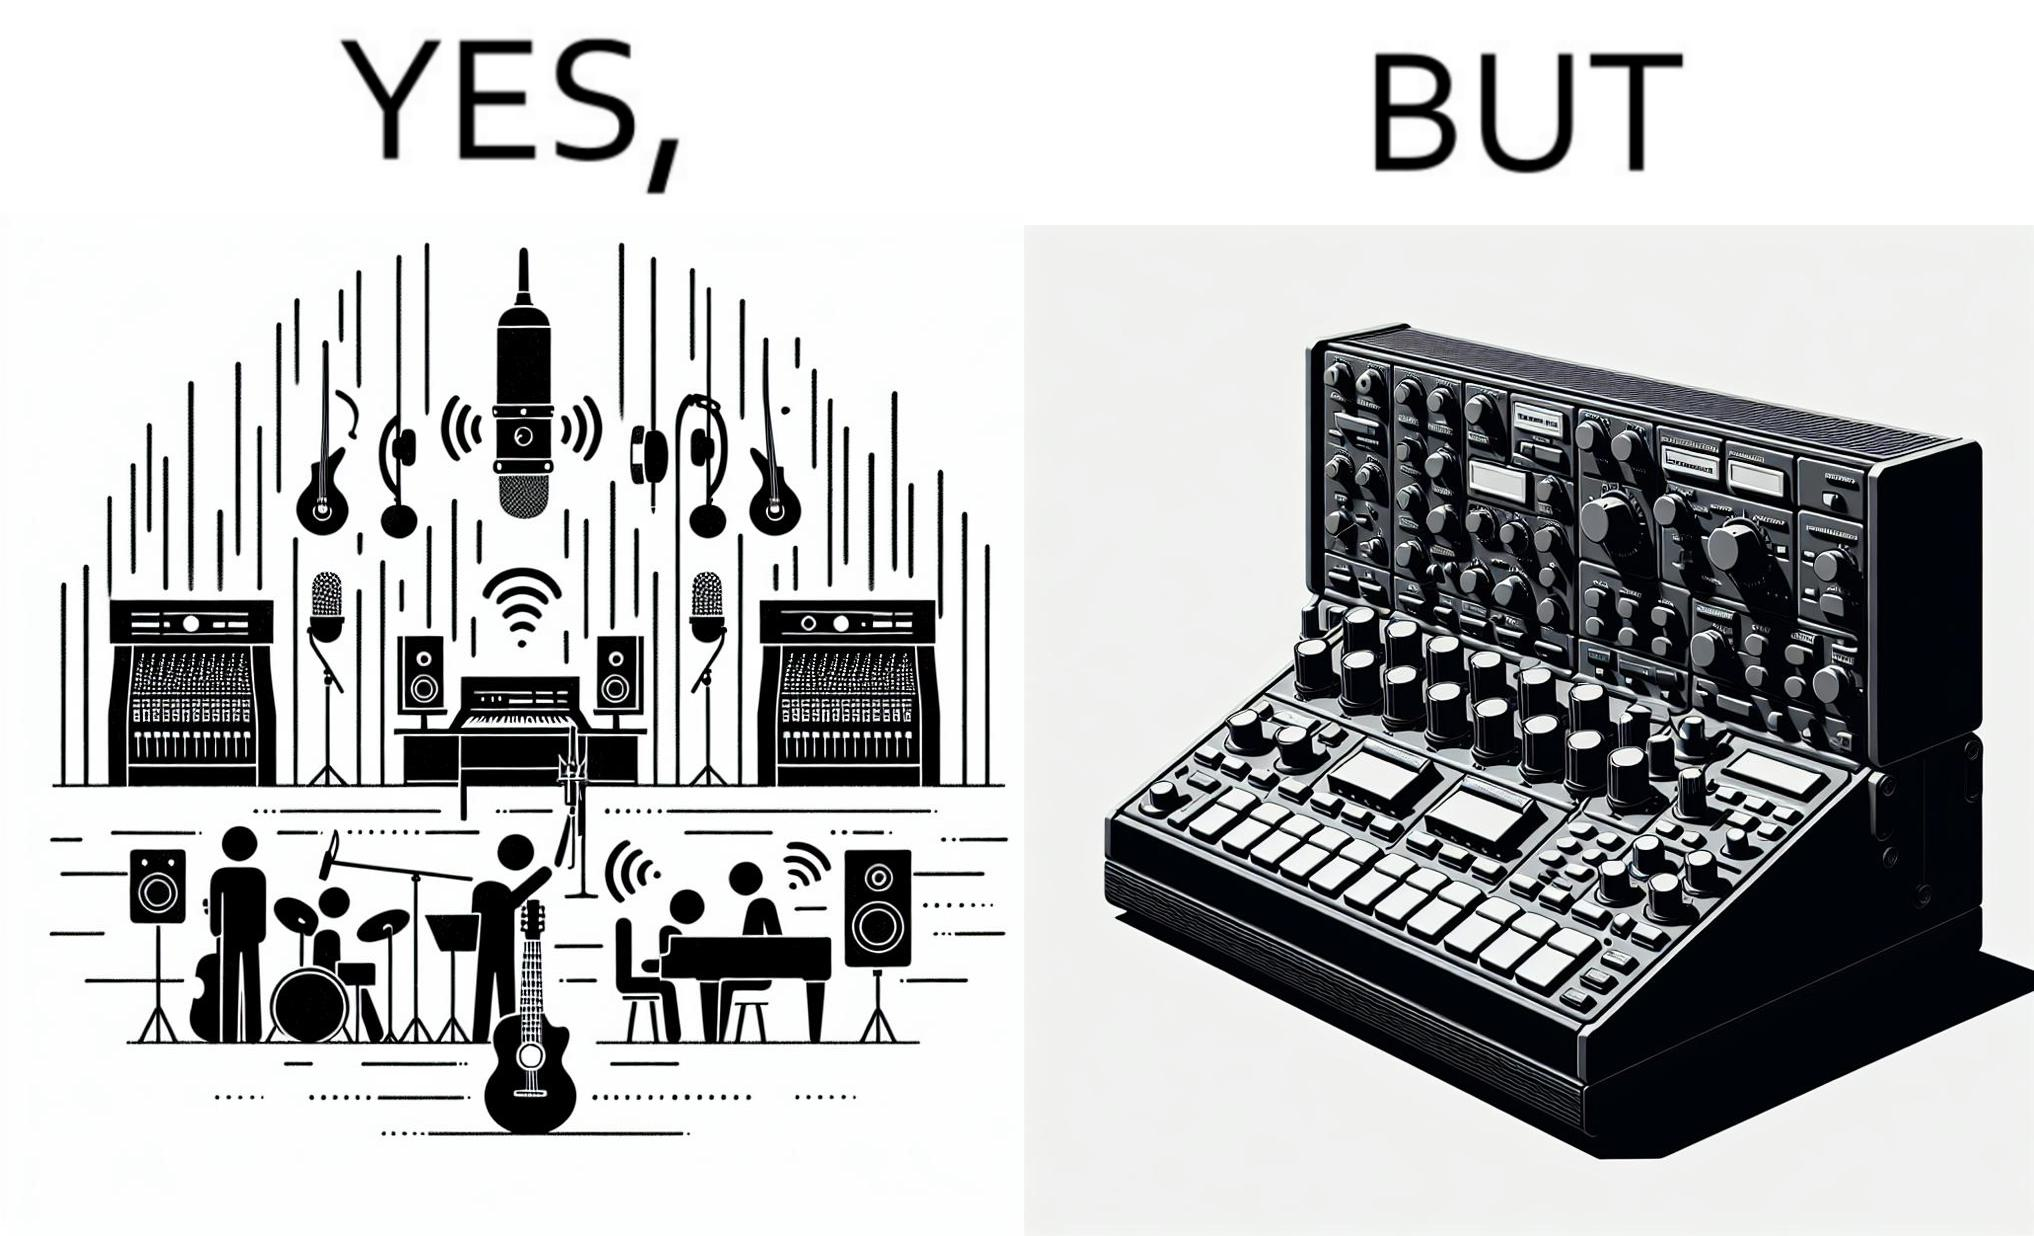Describe what you see in the left and right parts of this image. In the left part of the image: The image shows a music studio with differnt kinds of instruments like guitar and saxophone, piano and recording  to make music. In the right part of the image: The image shows the view of an electornic equipment used to create music. It has buttons to record, play drums and other musical instruments. 